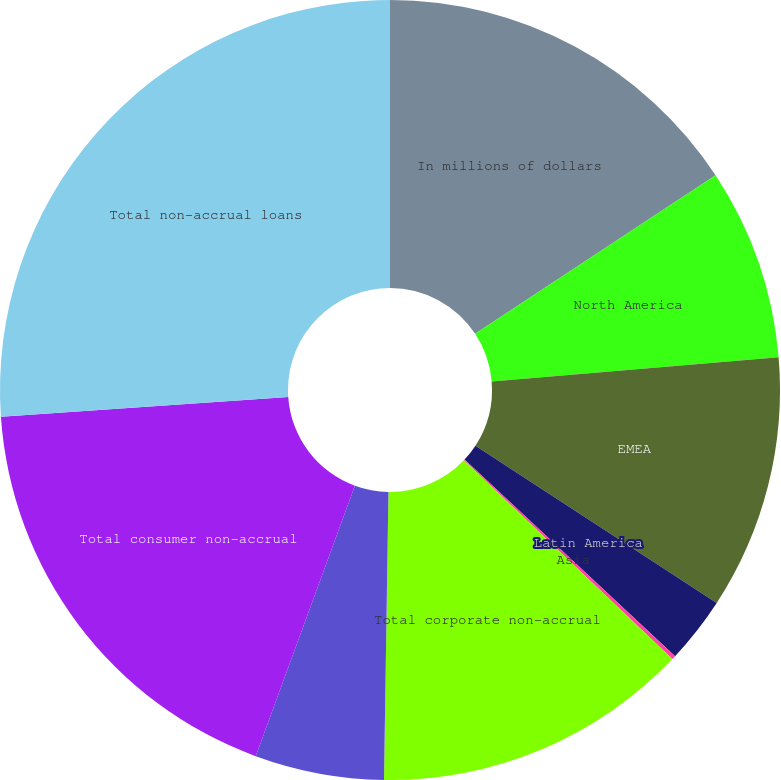Convert chart to OTSL. <chart><loc_0><loc_0><loc_500><loc_500><pie_chart><fcel>In millions of dollars<fcel>North America<fcel>EMEA<fcel>Latin America<fcel>Asia<fcel>Total corporate non-accrual<fcel>Asia (4)<fcel>Total consumer non-accrual<fcel>Total non-accrual loans<nl><fcel>15.72%<fcel>7.94%<fcel>10.53%<fcel>2.76%<fcel>0.16%<fcel>13.13%<fcel>5.35%<fcel>18.31%<fcel>26.09%<nl></chart> 